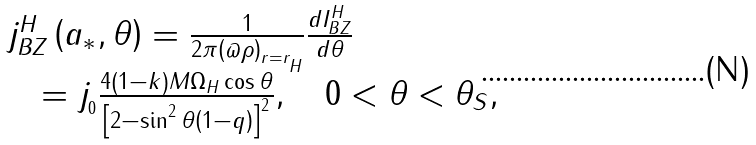Convert formula to latex. <formula><loc_0><loc_0><loc_500><loc_500>\begin{array} { l } j _ { B Z } ^ { H } \left ( { a _ { * } , \theta } \right ) = \frac { 1 } { 2 \pi \left ( { \varpi \rho } \right ) _ { r = r _ { _ { H } } } } \frac { d I _ { B Z } ^ { H } } { d \theta } \\ \quad = j _ { _ { 0 } } \frac { 4 \left ( { 1 - k } \right ) M \Omega _ { H } \cos \theta } { \left [ { 2 - \sin ^ { 2 } \theta \left ( { 1 - q } \right ) } \right ] ^ { 2 } } , \quad 0 < \theta < \theta _ { S } , \end{array}</formula> 